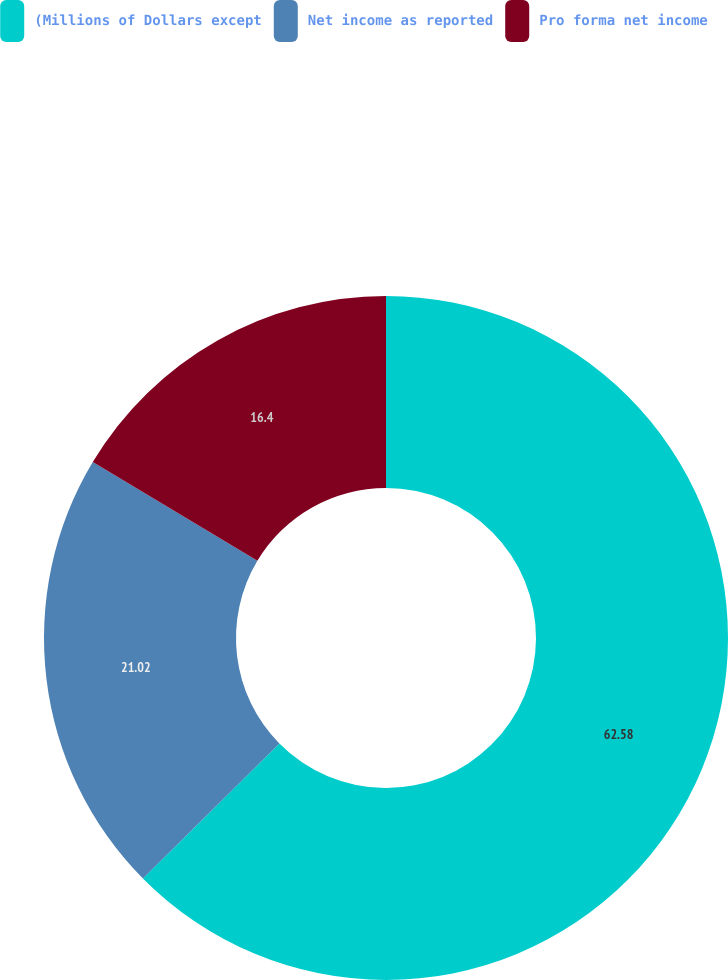Convert chart. <chart><loc_0><loc_0><loc_500><loc_500><pie_chart><fcel>(Millions of Dollars except<fcel>Net income as reported<fcel>Pro forma net income<nl><fcel>62.59%<fcel>21.02%<fcel>16.4%<nl></chart> 